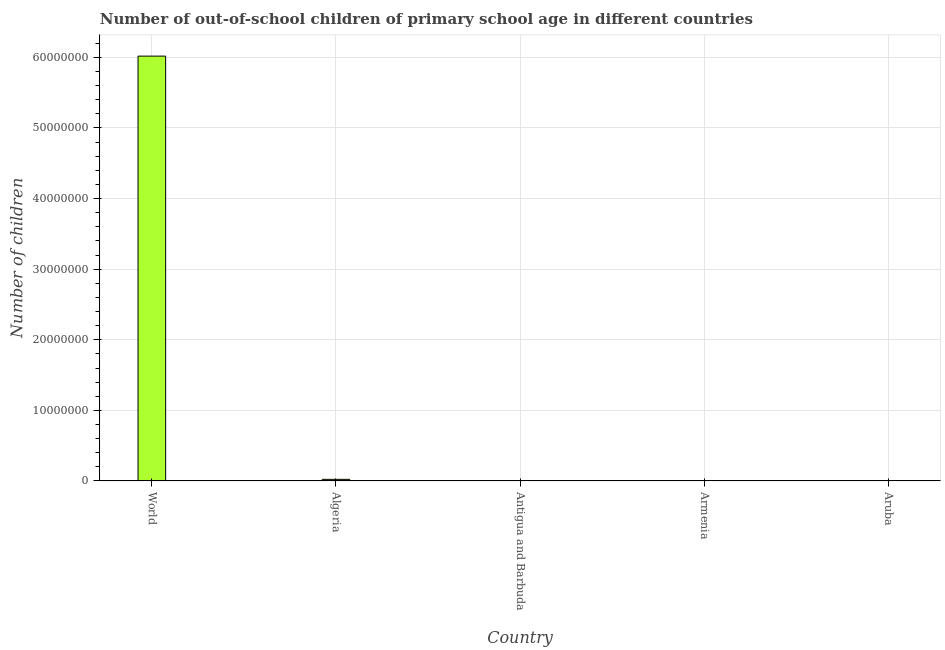What is the title of the graph?
Offer a very short reply. Number of out-of-school children of primary school age in different countries. What is the label or title of the X-axis?
Keep it short and to the point. Country. What is the label or title of the Y-axis?
Offer a terse response. Number of children. What is the number of out-of-school children in Aruba?
Offer a terse response. 96. Across all countries, what is the maximum number of out-of-school children?
Give a very brief answer. 6.02e+07. Across all countries, what is the minimum number of out-of-school children?
Offer a terse response. 96. In which country was the number of out-of-school children minimum?
Your response must be concise. Aruba. What is the sum of the number of out-of-school children?
Your response must be concise. 6.04e+07. What is the difference between the number of out-of-school children in Algeria and Antigua and Barbuda?
Offer a very short reply. 2.32e+05. What is the average number of out-of-school children per country?
Offer a terse response. 1.21e+07. What is the median number of out-of-school children?
Your response must be concise. 8314. What is the ratio of the number of out-of-school children in Algeria to that in Armenia?
Your answer should be compact. 27.95. Is the number of out-of-school children in Algeria less than that in Antigua and Barbuda?
Offer a terse response. No. What is the difference between the highest and the second highest number of out-of-school children?
Your response must be concise. 5.99e+07. What is the difference between the highest and the lowest number of out-of-school children?
Provide a short and direct response. 6.02e+07. How many bars are there?
Make the answer very short. 5. Are all the bars in the graph horizontal?
Keep it short and to the point. No. How many countries are there in the graph?
Your answer should be compact. 5. What is the Number of children in World?
Offer a very short reply. 6.02e+07. What is the Number of children of Algeria?
Make the answer very short. 2.32e+05. What is the Number of children of Antigua and Barbuda?
Offer a very short reply. 907. What is the Number of children in Armenia?
Give a very brief answer. 8314. What is the Number of children of Aruba?
Your answer should be very brief. 96. What is the difference between the Number of children in World and Algeria?
Give a very brief answer. 5.99e+07. What is the difference between the Number of children in World and Antigua and Barbuda?
Make the answer very short. 6.02e+07. What is the difference between the Number of children in World and Armenia?
Your response must be concise. 6.02e+07. What is the difference between the Number of children in World and Aruba?
Provide a succinct answer. 6.02e+07. What is the difference between the Number of children in Algeria and Antigua and Barbuda?
Keep it short and to the point. 2.32e+05. What is the difference between the Number of children in Algeria and Armenia?
Make the answer very short. 2.24e+05. What is the difference between the Number of children in Algeria and Aruba?
Offer a very short reply. 2.32e+05. What is the difference between the Number of children in Antigua and Barbuda and Armenia?
Ensure brevity in your answer.  -7407. What is the difference between the Number of children in Antigua and Barbuda and Aruba?
Your response must be concise. 811. What is the difference between the Number of children in Armenia and Aruba?
Your response must be concise. 8218. What is the ratio of the Number of children in World to that in Algeria?
Offer a terse response. 258.92. What is the ratio of the Number of children in World to that in Antigua and Barbuda?
Give a very brief answer. 6.64e+04. What is the ratio of the Number of children in World to that in Armenia?
Offer a very short reply. 7238.33. What is the ratio of the Number of children in World to that in Aruba?
Your answer should be very brief. 6.27e+05. What is the ratio of the Number of children in Algeria to that in Antigua and Barbuda?
Keep it short and to the point. 256.25. What is the ratio of the Number of children in Algeria to that in Armenia?
Your response must be concise. 27.95. What is the ratio of the Number of children in Algeria to that in Aruba?
Your answer should be very brief. 2421.05. What is the ratio of the Number of children in Antigua and Barbuda to that in Armenia?
Your response must be concise. 0.11. What is the ratio of the Number of children in Antigua and Barbuda to that in Aruba?
Give a very brief answer. 9.45. What is the ratio of the Number of children in Armenia to that in Aruba?
Your answer should be very brief. 86.6. 